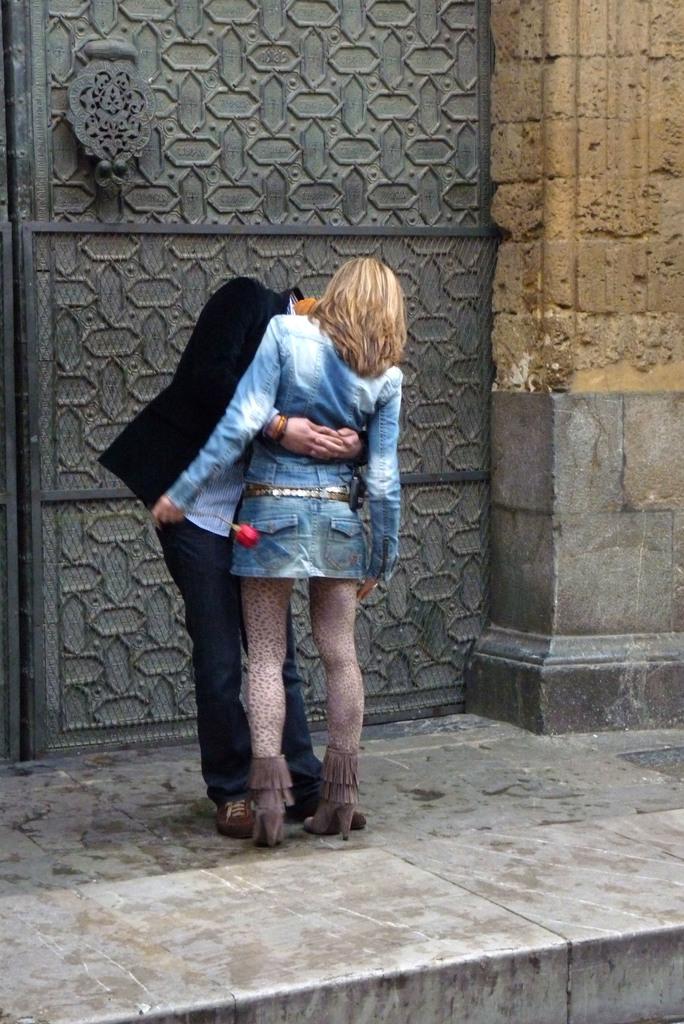How would you summarize this image in a sentence or two? In the image we can see there are people standing and behind there is an iron door. The woman is holding rose flower in her hand. 